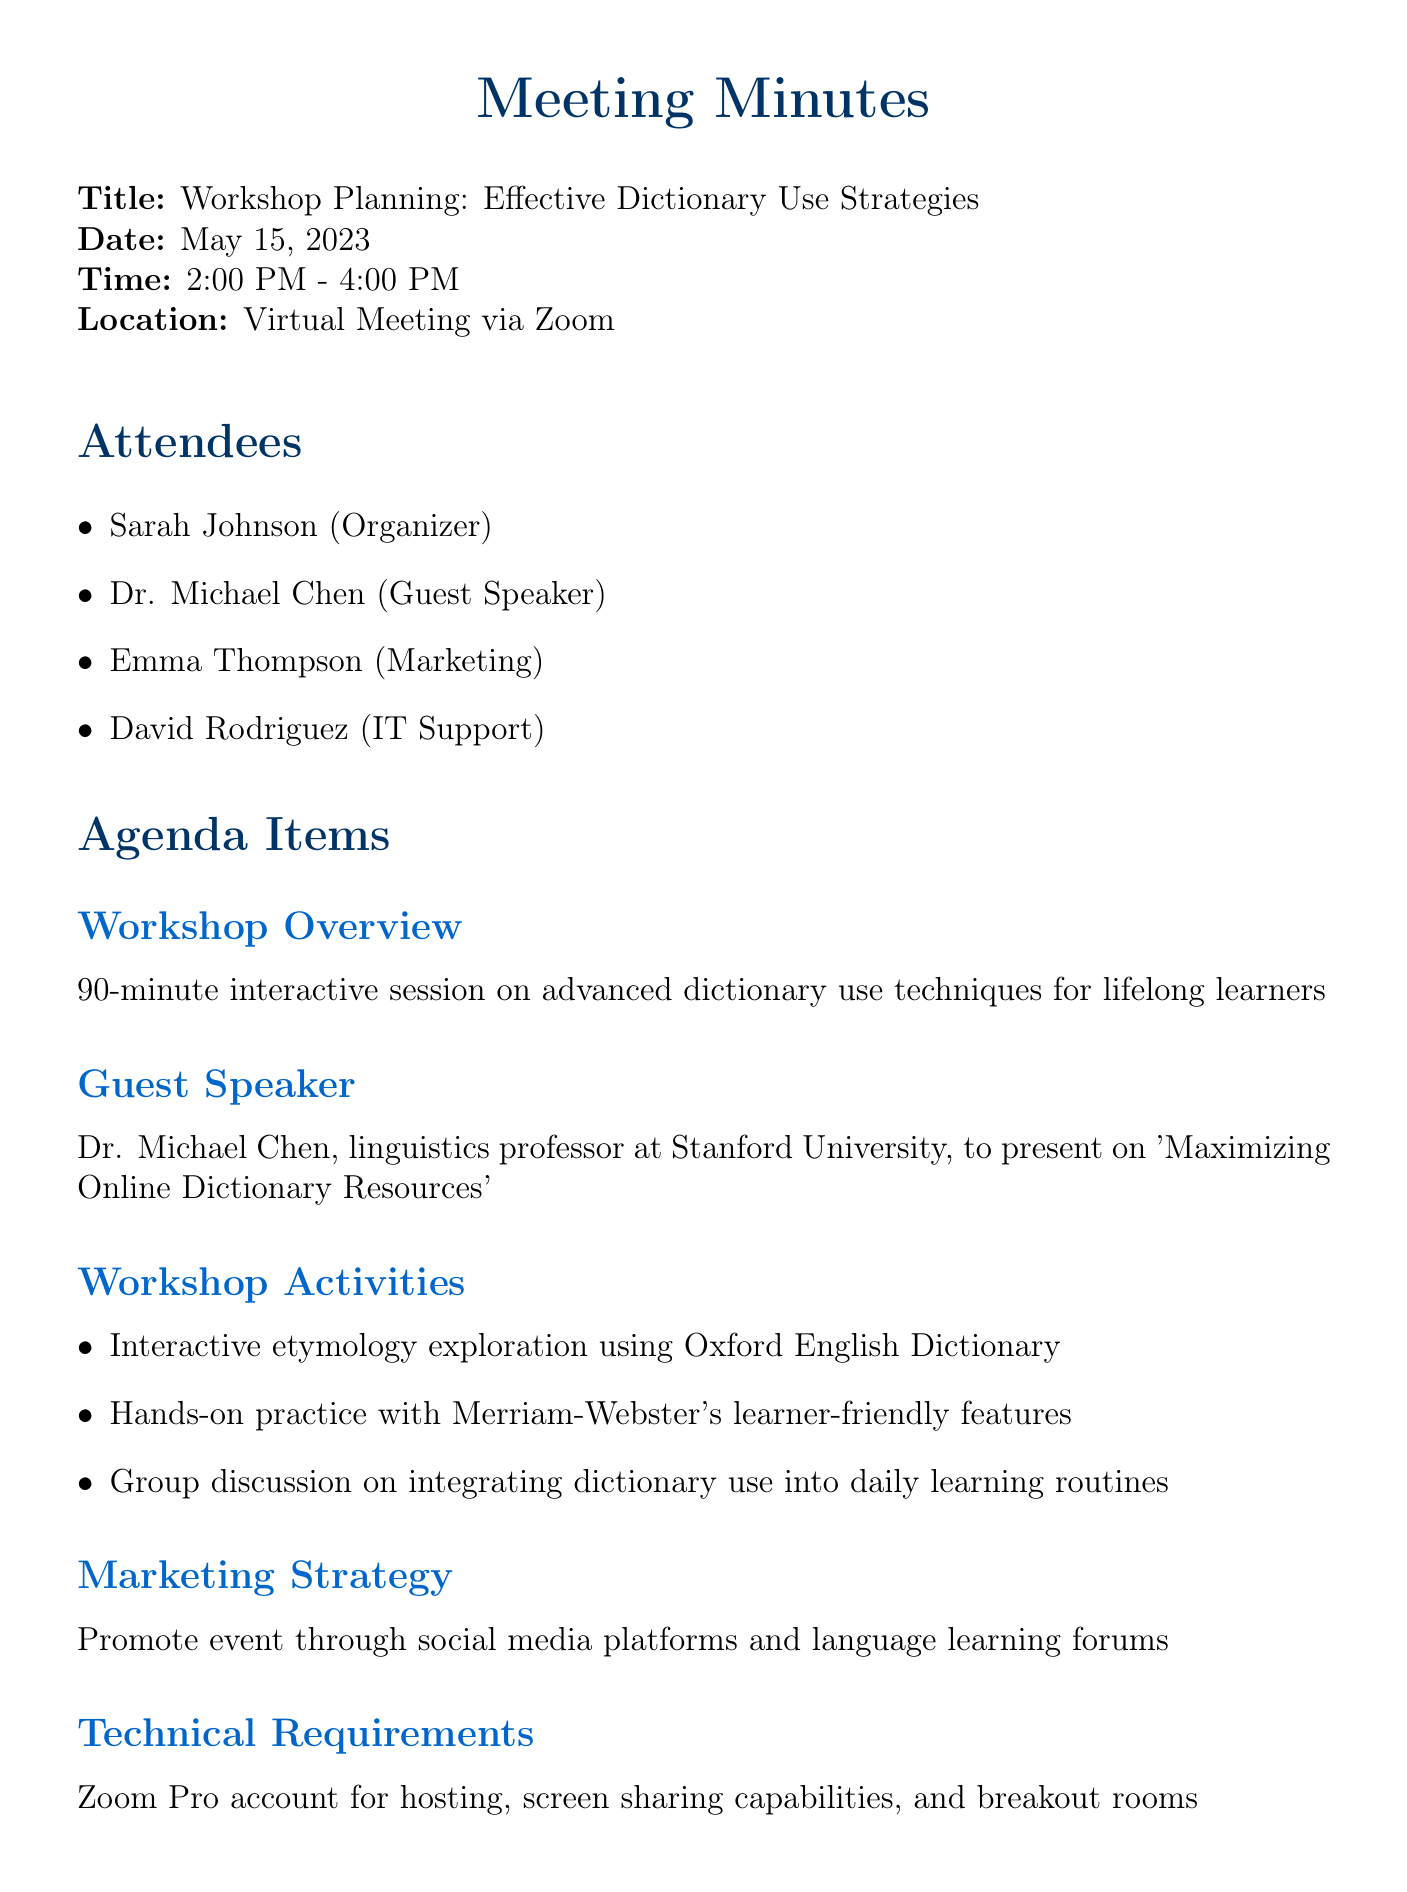What is the meeting title? The meeting title is stated at the beginning of the document.
Answer: Workshop Planning: Effective Dictionary Use Strategies Who is the guest speaker? The guest speaker's name is mentioned in the agenda item about the guest speaker.
Answer: Dr. Michael Chen What is the date of the next meeting? The date of the next meeting is clearly mentioned in the document.
Answer: May 29, 2023 How much is allocated for marketing materials? The budget allocation section specifies the amount dedicated to marketing materials.
Answer: $200 What is the duration of the workshop? The duration is included in the details about the workshop overview.
Answer: 90 minutes What platform will the workshop be hosted on? The location section indicates the platform for the workshop.
Answer: Zoom Which activity involves the Oxford English Dictionary? This activity is mentioned under the workshop activities section.
Answer: Interactive etymology exploration Who is responsible for creating promotional materials? The action items section specifies who is tasked with this responsibility.
Answer: Emma What is the total budget for the guest speaker's honorarium and marketing materials combined? The total is found by adding the two amounts listed in the budget allocation.
Answer: $700 